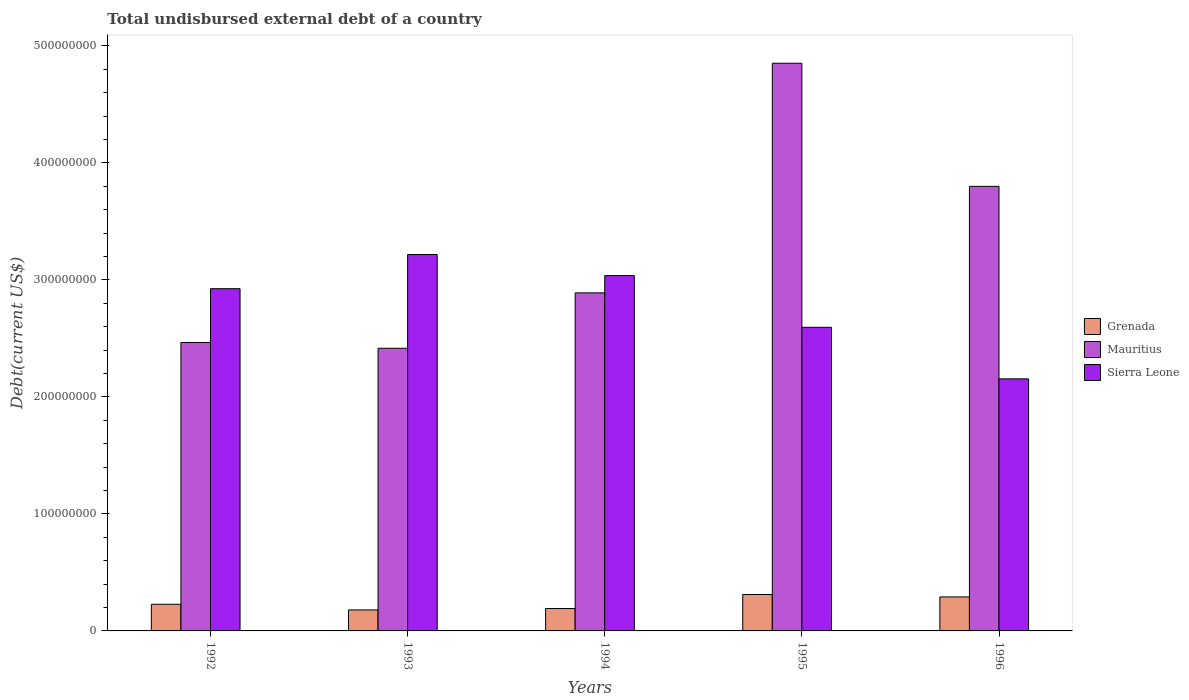How many different coloured bars are there?
Give a very brief answer. 3. How many groups of bars are there?
Your response must be concise. 5. Are the number of bars on each tick of the X-axis equal?
Your answer should be very brief. Yes. How many bars are there on the 1st tick from the right?
Offer a terse response. 3. In how many cases, is the number of bars for a given year not equal to the number of legend labels?
Ensure brevity in your answer.  0. What is the total undisbursed external debt in Sierra Leone in 1996?
Give a very brief answer. 2.15e+08. Across all years, what is the maximum total undisbursed external debt in Mauritius?
Your answer should be very brief. 4.85e+08. Across all years, what is the minimum total undisbursed external debt in Sierra Leone?
Keep it short and to the point. 2.15e+08. What is the total total undisbursed external debt in Mauritius in the graph?
Offer a terse response. 1.64e+09. What is the difference between the total undisbursed external debt in Mauritius in 1995 and that in 1996?
Your response must be concise. 1.05e+08. What is the difference between the total undisbursed external debt in Sierra Leone in 1992 and the total undisbursed external debt in Grenada in 1993?
Give a very brief answer. 2.75e+08. What is the average total undisbursed external debt in Sierra Leone per year?
Keep it short and to the point. 2.79e+08. In the year 1996, what is the difference between the total undisbursed external debt in Mauritius and total undisbursed external debt in Sierra Leone?
Offer a very short reply. 1.65e+08. What is the ratio of the total undisbursed external debt in Sierra Leone in 1993 to that in 1995?
Provide a short and direct response. 1.24. Is the total undisbursed external debt in Grenada in 1992 less than that in 1995?
Offer a terse response. Yes. Is the difference between the total undisbursed external debt in Mauritius in 1992 and 1996 greater than the difference between the total undisbursed external debt in Sierra Leone in 1992 and 1996?
Ensure brevity in your answer.  No. What is the difference between the highest and the second highest total undisbursed external debt in Sierra Leone?
Your answer should be compact. 1.80e+07. What is the difference between the highest and the lowest total undisbursed external debt in Mauritius?
Your answer should be compact. 2.44e+08. In how many years, is the total undisbursed external debt in Mauritius greater than the average total undisbursed external debt in Mauritius taken over all years?
Ensure brevity in your answer.  2. Is the sum of the total undisbursed external debt in Grenada in 1992 and 1996 greater than the maximum total undisbursed external debt in Mauritius across all years?
Give a very brief answer. No. What does the 2nd bar from the left in 1996 represents?
Give a very brief answer. Mauritius. What does the 2nd bar from the right in 1992 represents?
Offer a terse response. Mauritius. How many bars are there?
Offer a very short reply. 15. Are all the bars in the graph horizontal?
Provide a succinct answer. No. Are the values on the major ticks of Y-axis written in scientific E-notation?
Your answer should be compact. No. Does the graph contain grids?
Provide a succinct answer. No. Where does the legend appear in the graph?
Make the answer very short. Center right. How many legend labels are there?
Your answer should be compact. 3. How are the legend labels stacked?
Ensure brevity in your answer.  Vertical. What is the title of the graph?
Your response must be concise. Total undisbursed external debt of a country. Does "High income: nonOECD" appear as one of the legend labels in the graph?
Offer a very short reply. No. What is the label or title of the Y-axis?
Your response must be concise. Debt(current US$). What is the Debt(current US$) in Grenada in 1992?
Offer a very short reply. 2.28e+07. What is the Debt(current US$) of Mauritius in 1992?
Your answer should be compact. 2.46e+08. What is the Debt(current US$) of Sierra Leone in 1992?
Your answer should be compact. 2.92e+08. What is the Debt(current US$) of Grenada in 1993?
Your answer should be very brief. 1.79e+07. What is the Debt(current US$) in Mauritius in 1993?
Ensure brevity in your answer.  2.42e+08. What is the Debt(current US$) of Sierra Leone in 1993?
Provide a short and direct response. 3.22e+08. What is the Debt(current US$) of Grenada in 1994?
Make the answer very short. 1.91e+07. What is the Debt(current US$) in Mauritius in 1994?
Provide a succinct answer. 2.89e+08. What is the Debt(current US$) of Sierra Leone in 1994?
Your answer should be compact. 3.04e+08. What is the Debt(current US$) of Grenada in 1995?
Ensure brevity in your answer.  3.11e+07. What is the Debt(current US$) of Mauritius in 1995?
Ensure brevity in your answer.  4.85e+08. What is the Debt(current US$) of Sierra Leone in 1995?
Give a very brief answer. 2.59e+08. What is the Debt(current US$) in Grenada in 1996?
Your answer should be very brief. 2.90e+07. What is the Debt(current US$) in Mauritius in 1996?
Make the answer very short. 3.80e+08. What is the Debt(current US$) of Sierra Leone in 1996?
Your answer should be very brief. 2.15e+08. Across all years, what is the maximum Debt(current US$) in Grenada?
Your answer should be very brief. 3.11e+07. Across all years, what is the maximum Debt(current US$) of Mauritius?
Ensure brevity in your answer.  4.85e+08. Across all years, what is the maximum Debt(current US$) of Sierra Leone?
Provide a succinct answer. 3.22e+08. Across all years, what is the minimum Debt(current US$) in Grenada?
Provide a succinct answer. 1.79e+07. Across all years, what is the minimum Debt(current US$) of Mauritius?
Provide a succinct answer. 2.42e+08. Across all years, what is the minimum Debt(current US$) of Sierra Leone?
Keep it short and to the point. 2.15e+08. What is the total Debt(current US$) of Grenada in the graph?
Your response must be concise. 1.20e+08. What is the total Debt(current US$) in Mauritius in the graph?
Keep it short and to the point. 1.64e+09. What is the total Debt(current US$) in Sierra Leone in the graph?
Your response must be concise. 1.39e+09. What is the difference between the Debt(current US$) of Grenada in 1992 and that in 1993?
Provide a short and direct response. 4.84e+06. What is the difference between the Debt(current US$) in Mauritius in 1992 and that in 1993?
Provide a succinct answer. 4.93e+06. What is the difference between the Debt(current US$) in Sierra Leone in 1992 and that in 1993?
Keep it short and to the point. -2.92e+07. What is the difference between the Debt(current US$) in Grenada in 1992 and that in 1994?
Offer a very short reply. 3.63e+06. What is the difference between the Debt(current US$) of Mauritius in 1992 and that in 1994?
Provide a short and direct response. -4.24e+07. What is the difference between the Debt(current US$) in Sierra Leone in 1992 and that in 1994?
Offer a very short reply. -1.12e+07. What is the difference between the Debt(current US$) in Grenada in 1992 and that in 1995?
Provide a short and direct response. -8.35e+06. What is the difference between the Debt(current US$) of Mauritius in 1992 and that in 1995?
Ensure brevity in your answer.  -2.39e+08. What is the difference between the Debt(current US$) in Sierra Leone in 1992 and that in 1995?
Give a very brief answer. 3.30e+07. What is the difference between the Debt(current US$) in Grenada in 1992 and that in 1996?
Your response must be concise. -6.27e+06. What is the difference between the Debt(current US$) in Mauritius in 1992 and that in 1996?
Keep it short and to the point. -1.33e+08. What is the difference between the Debt(current US$) of Sierra Leone in 1992 and that in 1996?
Your response must be concise. 7.71e+07. What is the difference between the Debt(current US$) of Grenada in 1993 and that in 1994?
Offer a very short reply. -1.21e+06. What is the difference between the Debt(current US$) of Mauritius in 1993 and that in 1994?
Provide a succinct answer. -4.73e+07. What is the difference between the Debt(current US$) of Sierra Leone in 1993 and that in 1994?
Keep it short and to the point. 1.80e+07. What is the difference between the Debt(current US$) of Grenada in 1993 and that in 1995?
Keep it short and to the point. -1.32e+07. What is the difference between the Debt(current US$) in Mauritius in 1993 and that in 1995?
Your response must be concise. -2.44e+08. What is the difference between the Debt(current US$) of Sierra Leone in 1993 and that in 1995?
Give a very brief answer. 6.22e+07. What is the difference between the Debt(current US$) in Grenada in 1993 and that in 1996?
Provide a short and direct response. -1.11e+07. What is the difference between the Debt(current US$) in Mauritius in 1993 and that in 1996?
Your response must be concise. -1.38e+08. What is the difference between the Debt(current US$) in Sierra Leone in 1993 and that in 1996?
Your response must be concise. 1.06e+08. What is the difference between the Debt(current US$) in Grenada in 1994 and that in 1995?
Your response must be concise. -1.20e+07. What is the difference between the Debt(current US$) of Mauritius in 1994 and that in 1995?
Offer a very short reply. -1.96e+08. What is the difference between the Debt(current US$) in Sierra Leone in 1994 and that in 1995?
Offer a very short reply. 4.42e+07. What is the difference between the Debt(current US$) in Grenada in 1994 and that in 1996?
Your answer should be very brief. -9.90e+06. What is the difference between the Debt(current US$) of Mauritius in 1994 and that in 1996?
Provide a succinct answer. -9.10e+07. What is the difference between the Debt(current US$) of Sierra Leone in 1994 and that in 1996?
Keep it short and to the point. 8.83e+07. What is the difference between the Debt(current US$) in Grenada in 1995 and that in 1996?
Your answer should be very brief. 2.07e+06. What is the difference between the Debt(current US$) in Mauritius in 1995 and that in 1996?
Give a very brief answer. 1.05e+08. What is the difference between the Debt(current US$) of Sierra Leone in 1995 and that in 1996?
Keep it short and to the point. 4.40e+07. What is the difference between the Debt(current US$) in Grenada in 1992 and the Debt(current US$) in Mauritius in 1993?
Keep it short and to the point. -2.19e+08. What is the difference between the Debt(current US$) in Grenada in 1992 and the Debt(current US$) in Sierra Leone in 1993?
Your answer should be compact. -2.99e+08. What is the difference between the Debt(current US$) in Mauritius in 1992 and the Debt(current US$) in Sierra Leone in 1993?
Provide a succinct answer. -7.52e+07. What is the difference between the Debt(current US$) of Grenada in 1992 and the Debt(current US$) of Mauritius in 1994?
Provide a short and direct response. -2.66e+08. What is the difference between the Debt(current US$) of Grenada in 1992 and the Debt(current US$) of Sierra Leone in 1994?
Keep it short and to the point. -2.81e+08. What is the difference between the Debt(current US$) of Mauritius in 1992 and the Debt(current US$) of Sierra Leone in 1994?
Offer a very short reply. -5.72e+07. What is the difference between the Debt(current US$) of Grenada in 1992 and the Debt(current US$) of Mauritius in 1995?
Your answer should be compact. -4.62e+08. What is the difference between the Debt(current US$) of Grenada in 1992 and the Debt(current US$) of Sierra Leone in 1995?
Give a very brief answer. -2.37e+08. What is the difference between the Debt(current US$) in Mauritius in 1992 and the Debt(current US$) in Sierra Leone in 1995?
Provide a short and direct response. -1.30e+07. What is the difference between the Debt(current US$) of Grenada in 1992 and the Debt(current US$) of Mauritius in 1996?
Offer a terse response. -3.57e+08. What is the difference between the Debt(current US$) in Grenada in 1992 and the Debt(current US$) in Sierra Leone in 1996?
Offer a terse response. -1.93e+08. What is the difference between the Debt(current US$) of Mauritius in 1992 and the Debt(current US$) of Sierra Leone in 1996?
Keep it short and to the point. 3.11e+07. What is the difference between the Debt(current US$) in Grenada in 1993 and the Debt(current US$) in Mauritius in 1994?
Your response must be concise. -2.71e+08. What is the difference between the Debt(current US$) in Grenada in 1993 and the Debt(current US$) in Sierra Leone in 1994?
Keep it short and to the point. -2.86e+08. What is the difference between the Debt(current US$) of Mauritius in 1993 and the Debt(current US$) of Sierra Leone in 1994?
Keep it short and to the point. -6.21e+07. What is the difference between the Debt(current US$) of Grenada in 1993 and the Debt(current US$) of Mauritius in 1995?
Offer a terse response. -4.67e+08. What is the difference between the Debt(current US$) of Grenada in 1993 and the Debt(current US$) of Sierra Leone in 1995?
Your answer should be compact. -2.42e+08. What is the difference between the Debt(current US$) of Mauritius in 1993 and the Debt(current US$) of Sierra Leone in 1995?
Your answer should be very brief. -1.79e+07. What is the difference between the Debt(current US$) of Grenada in 1993 and the Debt(current US$) of Mauritius in 1996?
Give a very brief answer. -3.62e+08. What is the difference between the Debt(current US$) of Grenada in 1993 and the Debt(current US$) of Sierra Leone in 1996?
Give a very brief answer. -1.97e+08. What is the difference between the Debt(current US$) of Mauritius in 1993 and the Debt(current US$) of Sierra Leone in 1996?
Your answer should be very brief. 2.62e+07. What is the difference between the Debt(current US$) in Grenada in 1994 and the Debt(current US$) in Mauritius in 1995?
Ensure brevity in your answer.  -4.66e+08. What is the difference between the Debt(current US$) of Grenada in 1994 and the Debt(current US$) of Sierra Leone in 1995?
Your response must be concise. -2.40e+08. What is the difference between the Debt(current US$) of Mauritius in 1994 and the Debt(current US$) of Sierra Leone in 1995?
Offer a very short reply. 2.94e+07. What is the difference between the Debt(current US$) in Grenada in 1994 and the Debt(current US$) in Mauritius in 1996?
Your answer should be very brief. -3.61e+08. What is the difference between the Debt(current US$) of Grenada in 1994 and the Debt(current US$) of Sierra Leone in 1996?
Provide a succinct answer. -1.96e+08. What is the difference between the Debt(current US$) of Mauritius in 1994 and the Debt(current US$) of Sierra Leone in 1996?
Your answer should be very brief. 7.35e+07. What is the difference between the Debt(current US$) of Grenada in 1995 and the Debt(current US$) of Mauritius in 1996?
Give a very brief answer. -3.49e+08. What is the difference between the Debt(current US$) in Grenada in 1995 and the Debt(current US$) in Sierra Leone in 1996?
Make the answer very short. -1.84e+08. What is the difference between the Debt(current US$) of Mauritius in 1995 and the Debt(current US$) of Sierra Leone in 1996?
Keep it short and to the point. 2.70e+08. What is the average Debt(current US$) in Grenada per year?
Provide a short and direct response. 2.40e+07. What is the average Debt(current US$) in Mauritius per year?
Give a very brief answer. 3.28e+08. What is the average Debt(current US$) in Sierra Leone per year?
Give a very brief answer. 2.79e+08. In the year 1992, what is the difference between the Debt(current US$) in Grenada and Debt(current US$) in Mauritius?
Provide a succinct answer. -2.24e+08. In the year 1992, what is the difference between the Debt(current US$) of Grenada and Debt(current US$) of Sierra Leone?
Give a very brief answer. -2.70e+08. In the year 1992, what is the difference between the Debt(current US$) of Mauritius and Debt(current US$) of Sierra Leone?
Ensure brevity in your answer.  -4.60e+07. In the year 1993, what is the difference between the Debt(current US$) in Grenada and Debt(current US$) in Mauritius?
Your answer should be compact. -2.24e+08. In the year 1993, what is the difference between the Debt(current US$) of Grenada and Debt(current US$) of Sierra Leone?
Give a very brief answer. -3.04e+08. In the year 1993, what is the difference between the Debt(current US$) of Mauritius and Debt(current US$) of Sierra Leone?
Offer a terse response. -8.01e+07. In the year 1994, what is the difference between the Debt(current US$) in Grenada and Debt(current US$) in Mauritius?
Make the answer very short. -2.70e+08. In the year 1994, what is the difference between the Debt(current US$) in Grenada and Debt(current US$) in Sierra Leone?
Provide a short and direct response. -2.85e+08. In the year 1994, what is the difference between the Debt(current US$) in Mauritius and Debt(current US$) in Sierra Leone?
Give a very brief answer. -1.48e+07. In the year 1995, what is the difference between the Debt(current US$) in Grenada and Debt(current US$) in Mauritius?
Offer a very short reply. -4.54e+08. In the year 1995, what is the difference between the Debt(current US$) of Grenada and Debt(current US$) of Sierra Leone?
Offer a terse response. -2.28e+08. In the year 1995, what is the difference between the Debt(current US$) of Mauritius and Debt(current US$) of Sierra Leone?
Offer a terse response. 2.26e+08. In the year 1996, what is the difference between the Debt(current US$) of Grenada and Debt(current US$) of Mauritius?
Provide a short and direct response. -3.51e+08. In the year 1996, what is the difference between the Debt(current US$) in Grenada and Debt(current US$) in Sierra Leone?
Provide a succinct answer. -1.86e+08. In the year 1996, what is the difference between the Debt(current US$) in Mauritius and Debt(current US$) in Sierra Leone?
Offer a terse response. 1.65e+08. What is the ratio of the Debt(current US$) in Grenada in 1992 to that in 1993?
Your answer should be compact. 1.27. What is the ratio of the Debt(current US$) in Mauritius in 1992 to that in 1993?
Give a very brief answer. 1.02. What is the ratio of the Debt(current US$) of Sierra Leone in 1992 to that in 1993?
Keep it short and to the point. 0.91. What is the ratio of the Debt(current US$) in Grenada in 1992 to that in 1994?
Provide a succinct answer. 1.19. What is the ratio of the Debt(current US$) in Mauritius in 1992 to that in 1994?
Provide a short and direct response. 0.85. What is the ratio of the Debt(current US$) of Sierra Leone in 1992 to that in 1994?
Keep it short and to the point. 0.96. What is the ratio of the Debt(current US$) in Grenada in 1992 to that in 1995?
Offer a terse response. 0.73. What is the ratio of the Debt(current US$) in Mauritius in 1992 to that in 1995?
Keep it short and to the point. 0.51. What is the ratio of the Debt(current US$) in Sierra Leone in 1992 to that in 1995?
Ensure brevity in your answer.  1.13. What is the ratio of the Debt(current US$) of Grenada in 1992 to that in 1996?
Give a very brief answer. 0.78. What is the ratio of the Debt(current US$) in Mauritius in 1992 to that in 1996?
Your answer should be very brief. 0.65. What is the ratio of the Debt(current US$) in Sierra Leone in 1992 to that in 1996?
Give a very brief answer. 1.36. What is the ratio of the Debt(current US$) in Grenada in 1993 to that in 1994?
Your answer should be very brief. 0.94. What is the ratio of the Debt(current US$) in Mauritius in 1993 to that in 1994?
Provide a short and direct response. 0.84. What is the ratio of the Debt(current US$) of Sierra Leone in 1993 to that in 1994?
Offer a very short reply. 1.06. What is the ratio of the Debt(current US$) in Grenada in 1993 to that in 1995?
Your answer should be very brief. 0.58. What is the ratio of the Debt(current US$) in Mauritius in 1993 to that in 1995?
Keep it short and to the point. 0.5. What is the ratio of the Debt(current US$) of Sierra Leone in 1993 to that in 1995?
Make the answer very short. 1.24. What is the ratio of the Debt(current US$) in Grenada in 1993 to that in 1996?
Make the answer very short. 0.62. What is the ratio of the Debt(current US$) in Mauritius in 1993 to that in 1996?
Your response must be concise. 0.64. What is the ratio of the Debt(current US$) of Sierra Leone in 1993 to that in 1996?
Your answer should be very brief. 1.49. What is the ratio of the Debt(current US$) of Grenada in 1994 to that in 1995?
Provide a succinct answer. 0.62. What is the ratio of the Debt(current US$) in Mauritius in 1994 to that in 1995?
Your response must be concise. 0.6. What is the ratio of the Debt(current US$) in Sierra Leone in 1994 to that in 1995?
Your answer should be compact. 1.17. What is the ratio of the Debt(current US$) of Grenada in 1994 to that in 1996?
Ensure brevity in your answer.  0.66. What is the ratio of the Debt(current US$) of Mauritius in 1994 to that in 1996?
Your answer should be compact. 0.76. What is the ratio of the Debt(current US$) of Sierra Leone in 1994 to that in 1996?
Keep it short and to the point. 1.41. What is the ratio of the Debt(current US$) in Grenada in 1995 to that in 1996?
Provide a succinct answer. 1.07. What is the ratio of the Debt(current US$) of Mauritius in 1995 to that in 1996?
Offer a terse response. 1.28. What is the ratio of the Debt(current US$) in Sierra Leone in 1995 to that in 1996?
Your answer should be compact. 1.2. What is the difference between the highest and the second highest Debt(current US$) in Grenada?
Provide a succinct answer. 2.07e+06. What is the difference between the highest and the second highest Debt(current US$) in Mauritius?
Your answer should be compact. 1.05e+08. What is the difference between the highest and the second highest Debt(current US$) in Sierra Leone?
Give a very brief answer. 1.80e+07. What is the difference between the highest and the lowest Debt(current US$) in Grenada?
Make the answer very short. 1.32e+07. What is the difference between the highest and the lowest Debt(current US$) of Mauritius?
Offer a terse response. 2.44e+08. What is the difference between the highest and the lowest Debt(current US$) of Sierra Leone?
Provide a short and direct response. 1.06e+08. 